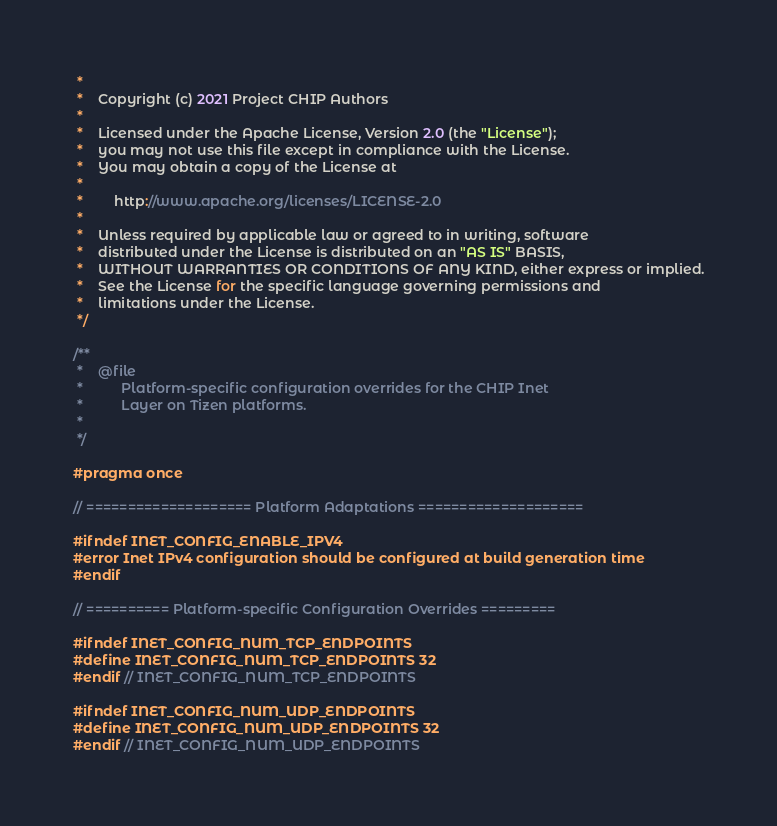<code> <loc_0><loc_0><loc_500><loc_500><_C_> *
 *    Copyright (c) 2021 Project CHIP Authors
 *
 *    Licensed under the Apache License, Version 2.0 (the "License");
 *    you may not use this file except in compliance with the License.
 *    You may obtain a copy of the License at
 *
 *        http://www.apache.org/licenses/LICENSE-2.0
 *
 *    Unless required by applicable law or agreed to in writing, software
 *    distributed under the License is distributed on an "AS IS" BASIS,
 *    WITHOUT WARRANTIES OR CONDITIONS OF ANY KIND, either express or implied.
 *    See the License for the specific language governing permissions and
 *    limitations under the License.
 */

/**
 *    @file
 *          Platform-specific configuration overrides for the CHIP Inet
 *          Layer on Tizen platforms.
 *
 */

#pragma once

// ==================== Platform Adaptations ====================

#ifndef INET_CONFIG_ENABLE_IPV4
#error Inet IPv4 configuration should be configured at build generation time
#endif

// ========== Platform-specific Configuration Overrides =========

#ifndef INET_CONFIG_NUM_TCP_ENDPOINTS
#define INET_CONFIG_NUM_TCP_ENDPOINTS 32
#endif // INET_CONFIG_NUM_TCP_ENDPOINTS

#ifndef INET_CONFIG_NUM_UDP_ENDPOINTS
#define INET_CONFIG_NUM_UDP_ENDPOINTS 32
#endif // INET_CONFIG_NUM_UDP_ENDPOINTS
</code> 